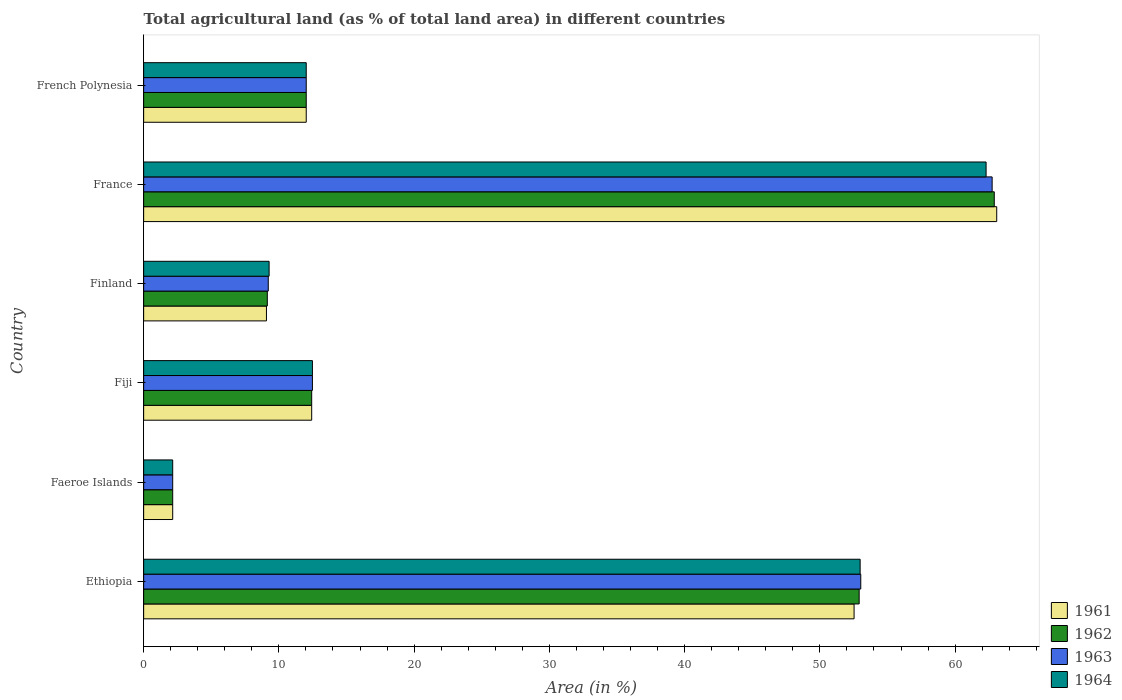How many groups of bars are there?
Give a very brief answer. 6. Are the number of bars on each tick of the Y-axis equal?
Your answer should be very brief. Yes. How many bars are there on the 6th tick from the top?
Keep it short and to the point. 4. What is the label of the 1st group of bars from the top?
Provide a succinct answer. French Polynesia. What is the percentage of agricultural land in 1961 in Finland?
Make the answer very short. 9.08. Across all countries, what is the maximum percentage of agricultural land in 1964?
Your answer should be very brief. 62.29. Across all countries, what is the minimum percentage of agricultural land in 1962?
Provide a succinct answer. 2.15. In which country was the percentage of agricultural land in 1961 minimum?
Provide a succinct answer. Faeroe Islands. What is the total percentage of agricultural land in 1962 in the graph?
Your answer should be compact. 151.54. What is the difference between the percentage of agricultural land in 1962 in Ethiopia and that in Faeroe Islands?
Your response must be concise. 50.76. What is the difference between the percentage of agricultural land in 1962 in Faeroe Islands and the percentage of agricultural land in 1963 in Ethiopia?
Give a very brief answer. -50.88. What is the average percentage of agricultural land in 1961 per country?
Your response must be concise. 25.21. What is the difference between the percentage of agricultural land in 1964 and percentage of agricultural land in 1961 in Fiji?
Make the answer very short. 0.05. In how many countries, is the percentage of agricultural land in 1961 greater than 18 %?
Keep it short and to the point. 2. What is the ratio of the percentage of agricultural land in 1962 in Faeroe Islands to that in France?
Your answer should be compact. 0.03. Is the percentage of agricultural land in 1963 in Faeroe Islands less than that in France?
Offer a terse response. Yes. Is the difference between the percentage of agricultural land in 1964 in France and French Polynesia greater than the difference between the percentage of agricultural land in 1961 in France and French Polynesia?
Your answer should be compact. No. What is the difference between the highest and the second highest percentage of agricultural land in 1964?
Offer a very short reply. 9.31. What is the difference between the highest and the lowest percentage of agricultural land in 1962?
Offer a terse response. 60.75. Is it the case that in every country, the sum of the percentage of agricultural land in 1964 and percentage of agricultural land in 1963 is greater than the sum of percentage of agricultural land in 1961 and percentage of agricultural land in 1962?
Make the answer very short. No. What does the 3rd bar from the top in Fiji represents?
Make the answer very short. 1962. What does the 1st bar from the bottom in France represents?
Provide a succinct answer. 1961. Is it the case that in every country, the sum of the percentage of agricultural land in 1962 and percentage of agricultural land in 1963 is greater than the percentage of agricultural land in 1961?
Provide a short and direct response. Yes. How many bars are there?
Provide a short and direct response. 24. Are all the bars in the graph horizontal?
Ensure brevity in your answer.  Yes. How many countries are there in the graph?
Provide a short and direct response. 6. Are the values on the major ticks of X-axis written in scientific E-notation?
Give a very brief answer. No. Does the graph contain any zero values?
Give a very brief answer. No. Does the graph contain grids?
Your answer should be compact. No. How are the legend labels stacked?
Offer a very short reply. Vertical. What is the title of the graph?
Your answer should be compact. Total agricultural land (as % of total land area) in different countries. What is the label or title of the X-axis?
Your answer should be very brief. Area (in %). What is the label or title of the Y-axis?
Offer a terse response. Country. What is the Area (in %) in 1961 in Ethiopia?
Make the answer very short. 52.53. What is the Area (in %) of 1962 in Ethiopia?
Provide a succinct answer. 52.91. What is the Area (in %) of 1963 in Ethiopia?
Keep it short and to the point. 53.02. What is the Area (in %) in 1964 in Ethiopia?
Ensure brevity in your answer.  52.98. What is the Area (in %) of 1961 in Faeroe Islands?
Give a very brief answer. 2.15. What is the Area (in %) of 1962 in Faeroe Islands?
Your response must be concise. 2.15. What is the Area (in %) of 1963 in Faeroe Islands?
Give a very brief answer. 2.15. What is the Area (in %) in 1964 in Faeroe Islands?
Provide a short and direct response. 2.15. What is the Area (in %) in 1961 in Fiji?
Make the answer very short. 12.42. What is the Area (in %) of 1962 in Fiji?
Provide a short and direct response. 12.42. What is the Area (in %) of 1963 in Fiji?
Offer a terse response. 12.48. What is the Area (in %) of 1964 in Fiji?
Your response must be concise. 12.48. What is the Area (in %) of 1961 in Finland?
Your answer should be compact. 9.08. What is the Area (in %) of 1962 in Finland?
Give a very brief answer. 9.14. What is the Area (in %) in 1963 in Finland?
Ensure brevity in your answer.  9.21. What is the Area (in %) in 1964 in Finland?
Ensure brevity in your answer.  9.28. What is the Area (in %) in 1961 in France?
Your response must be concise. 63.08. What is the Area (in %) in 1962 in France?
Your answer should be very brief. 62.9. What is the Area (in %) of 1963 in France?
Offer a terse response. 62.74. What is the Area (in %) in 1964 in France?
Give a very brief answer. 62.29. What is the Area (in %) in 1961 in French Polynesia?
Keep it short and to the point. 12.02. What is the Area (in %) of 1962 in French Polynesia?
Your answer should be compact. 12.02. What is the Area (in %) in 1963 in French Polynesia?
Give a very brief answer. 12.02. What is the Area (in %) of 1964 in French Polynesia?
Keep it short and to the point. 12.02. Across all countries, what is the maximum Area (in %) in 1961?
Offer a terse response. 63.08. Across all countries, what is the maximum Area (in %) of 1962?
Provide a succinct answer. 62.9. Across all countries, what is the maximum Area (in %) in 1963?
Offer a terse response. 62.74. Across all countries, what is the maximum Area (in %) in 1964?
Make the answer very short. 62.29. Across all countries, what is the minimum Area (in %) in 1961?
Keep it short and to the point. 2.15. Across all countries, what is the minimum Area (in %) in 1962?
Your answer should be compact. 2.15. Across all countries, what is the minimum Area (in %) of 1963?
Ensure brevity in your answer.  2.15. Across all countries, what is the minimum Area (in %) in 1964?
Keep it short and to the point. 2.15. What is the total Area (in %) in 1961 in the graph?
Offer a terse response. 151.28. What is the total Area (in %) of 1962 in the graph?
Give a very brief answer. 151.54. What is the total Area (in %) of 1963 in the graph?
Provide a short and direct response. 151.63. What is the total Area (in %) of 1964 in the graph?
Your answer should be compact. 151.2. What is the difference between the Area (in %) in 1961 in Ethiopia and that in Faeroe Islands?
Give a very brief answer. 50.38. What is the difference between the Area (in %) in 1962 in Ethiopia and that in Faeroe Islands?
Your response must be concise. 50.76. What is the difference between the Area (in %) of 1963 in Ethiopia and that in Faeroe Islands?
Ensure brevity in your answer.  50.88. What is the difference between the Area (in %) of 1964 in Ethiopia and that in Faeroe Islands?
Provide a short and direct response. 50.83. What is the difference between the Area (in %) of 1961 in Ethiopia and that in Fiji?
Make the answer very short. 40.11. What is the difference between the Area (in %) in 1962 in Ethiopia and that in Fiji?
Offer a terse response. 40.48. What is the difference between the Area (in %) in 1963 in Ethiopia and that in Fiji?
Offer a terse response. 40.55. What is the difference between the Area (in %) in 1964 in Ethiopia and that in Fiji?
Your answer should be very brief. 40.5. What is the difference between the Area (in %) in 1961 in Ethiopia and that in Finland?
Offer a very short reply. 43.45. What is the difference between the Area (in %) of 1962 in Ethiopia and that in Finland?
Make the answer very short. 43.76. What is the difference between the Area (in %) in 1963 in Ethiopia and that in Finland?
Make the answer very short. 43.81. What is the difference between the Area (in %) of 1964 in Ethiopia and that in Finland?
Offer a very short reply. 43.7. What is the difference between the Area (in %) in 1961 in Ethiopia and that in France?
Make the answer very short. -10.55. What is the difference between the Area (in %) in 1962 in Ethiopia and that in France?
Keep it short and to the point. -9.99. What is the difference between the Area (in %) of 1963 in Ethiopia and that in France?
Your answer should be compact. -9.71. What is the difference between the Area (in %) in 1964 in Ethiopia and that in France?
Provide a short and direct response. -9.31. What is the difference between the Area (in %) of 1961 in Ethiopia and that in French Polynesia?
Keep it short and to the point. 40.51. What is the difference between the Area (in %) in 1962 in Ethiopia and that in French Polynesia?
Your response must be concise. 40.88. What is the difference between the Area (in %) of 1963 in Ethiopia and that in French Polynesia?
Your answer should be very brief. 41. What is the difference between the Area (in %) of 1964 in Ethiopia and that in French Polynesia?
Offer a very short reply. 40.96. What is the difference between the Area (in %) in 1961 in Faeroe Islands and that in Fiji?
Offer a very short reply. -10.28. What is the difference between the Area (in %) of 1962 in Faeroe Islands and that in Fiji?
Keep it short and to the point. -10.28. What is the difference between the Area (in %) in 1963 in Faeroe Islands and that in Fiji?
Provide a succinct answer. -10.33. What is the difference between the Area (in %) of 1964 in Faeroe Islands and that in Fiji?
Offer a very short reply. -10.33. What is the difference between the Area (in %) in 1961 in Faeroe Islands and that in Finland?
Ensure brevity in your answer.  -6.93. What is the difference between the Area (in %) of 1962 in Faeroe Islands and that in Finland?
Give a very brief answer. -6.99. What is the difference between the Area (in %) in 1963 in Faeroe Islands and that in Finland?
Offer a very short reply. -7.07. What is the difference between the Area (in %) in 1964 in Faeroe Islands and that in Finland?
Your response must be concise. -7.13. What is the difference between the Area (in %) of 1961 in Faeroe Islands and that in France?
Give a very brief answer. -60.93. What is the difference between the Area (in %) in 1962 in Faeroe Islands and that in France?
Provide a short and direct response. -60.75. What is the difference between the Area (in %) in 1963 in Faeroe Islands and that in France?
Make the answer very short. -60.59. What is the difference between the Area (in %) in 1964 in Faeroe Islands and that in France?
Offer a very short reply. -60.14. What is the difference between the Area (in %) in 1961 in Faeroe Islands and that in French Polynesia?
Offer a very short reply. -9.87. What is the difference between the Area (in %) in 1962 in Faeroe Islands and that in French Polynesia?
Offer a very short reply. -9.87. What is the difference between the Area (in %) in 1963 in Faeroe Islands and that in French Polynesia?
Your answer should be very brief. -9.87. What is the difference between the Area (in %) of 1964 in Faeroe Islands and that in French Polynesia?
Keep it short and to the point. -9.87. What is the difference between the Area (in %) in 1961 in Fiji and that in Finland?
Keep it short and to the point. 3.34. What is the difference between the Area (in %) of 1962 in Fiji and that in Finland?
Offer a terse response. 3.28. What is the difference between the Area (in %) in 1963 in Fiji and that in Finland?
Your answer should be compact. 3.27. What is the difference between the Area (in %) of 1964 in Fiji and that in Finland?
Offer a very short reply. 3.2. What is the difference between the Area (in %) of 1961 in Fiji and that in France?
Ensure brevity in your answer.  -50.65. What is the difference between the Area (in %) in 1962 in Fiji and that in France?
Keep it short and to the point. -50.47. What is the difference between the Area (in %) in 1963 in Fiji and that in France?
Your response must be concise. -50.26. What is the difference between the Area (in %) in 1964 in Fiji and that in France?
Give a very brief answer. -49.81. What is the difference between the Area (in %) of 1961 in Fiji and that in French Polynesia?
Offer a terse response. 0.4. What is the difference between the Area (in %) in 1962 in Fiji and that in French Polynesia?
Your answer should be compact. 0.4. What is the difference between the Area (in %) of 1963 in Fiji and that in French Polynesia?
Your answer should be compact. 0.46. What is the difference between the Area (in %) in 1964 in Fiji and that in French Polynesia?
Offer a terse response. 0.46. What is the difference between the Area (in %) of 1961 in Finland and that in France?
Your answer should be very brief. -54. What is the difference between the Area (in %) in 1962 in Finland and that in France?
Give a very brief answer. -53.75. What is the difference between the Area (in %) in 1963 in Finland and that in France?
Offer a terse response. -53.53. What is the difference between the Area (in %) in 1964 in Finland and that in France?
Give a very brief answer. -53.02. What is the difference between the Area (in %) in 1961 in Finland and that in French Polynesia?
Provide a succinct answer. -2.94. What is the difference between the Area (in %) in 1962 in Finland and that in French Polynesia?
Give a very brief answer. -2.88. What is the difference between the Area (in %) in 1963 in Finland and that in French Polynesia?
Ensure brevity in your answer.  -2.81. What is the difference between the Area (in %) of 1964 in Finland and that in French Polynesia?
Your answer should be very brief. -2.75. What is the difference between the Area (in %) of 1961 in France and that in French Polynesia?
Provide a succinct answer. 51.06. What is the difference between the Area (in %) in 1962 in France and that in French Polynesia?
Ensure brevity in your answer.  50.87. What is the difference between the Area (in %) of 1963 in France and that in French Polynesia?
Provide a short and direct response. 50.72. What is the difference between the Area (in %) in 1964 in France and that in French Polynesia?
Ensure brevity in your answer.  50.27. What is the difference between the Area (in %) in 1961 in Ethiopia and the Area (in %) in 1962 in Faeroe Islands?
Your response must be concise. 50.38. What is the difference between the Area (in %) in 1961 in Ethiopia and the Area (in %) in 1963 in Faeroe Islands?
Give a very brief answer. 50.38. What is the difference between the Area (in %) in 1961 in Ethiopia and the Area (in %) in 1964 in Faeroe Islands?
Keep it short and to the point. 50.38. What is the difference between the Area (in %) in 1962 in Ethiopia and the Area (in %) in 1963 in Faeroe Islands?
Your answer should be very brief. 50.76. What is the difference between the Area (in %) of 1962 in Ethiopia and the Area (in %) of 1964 in Faeroe Islands?
Offer a terse response. 50.76. What is the difference between the Area (in %) of 1963 in Ethiopia and the Area (in %) of 1964 in Faeroe Islands?
Offer a very short reply. 50.88. What is the difference between the Area (in %) in 1961 in Ethiopia and the Area (in %) in 1962 in Fiji?
Keep it short and to the point. 40.11. What is the difference between the Area (in %) of 1961 in Ethiopia and the Area (in %) of 1963 in Fiji?
Your answer should be very brief. 40.05. What is the difference between the Area (in %) of 1961 in Ethiopia and the Area (in %) of 1964 in Fiji?
Keep it short and to the point. 40.05. What is the difference between the Area (in %) in 1962 in Ethiopia and the Area (in %) in 1963 in Fiji?
Provide a succinct answer. 40.43. What is the difference between the Area (in %) in 1962 in Ethiopia and the Area (in %) in 1964 in Fiji?
Offer a terse response. 40.43. What is the difference between the Area (in %) in 1963 in Ethiopia and the Area (in %) in 1964 in Fiji?
Your answer should be very brief. 40.55. What is the difference between the Area (in %) in 1961 in Ethiopia and the Area (in %) in 1962 in Finland?
Offer a very short reply. 43.39. What is the difference between the Area (in %) in 1961 in Ethiopia and the Area (in %) in 1963 in Finland?
Give a very brief answer. 43.32. What is the difference between the Area (in %) in 1961 in Ethiopia and the Area (in %) in 1964 in Finland?
Make the answer very short. 43.25. What is the difference between the Area (in %) of 1962 in Ethiopia and the Area (in %) of 1963 in Finland?
Provide a short and direct response. 43.69. What is the difference between the Area (in %) in 1962 in Ethiopia and the Area (in %) in 1964 in Finland?
Provide a succinct answer. 43.63. What is the difference between the Area (in %) in 1963 in Ethiopia and the Area (in %) in 1964 in Finland?
Offer a very short reply. 43.75. What is the difference between the Area (in %) in 1961 in Ethiopia and the Area (in %) in 1962 in France?
Provide a short and direct response. -10.37. What is the difference between the Area (in %) of 1961 in Ethiopia and the Area (in %) of 1963 in France?
Your answer should be very brief. -10.21. What is the difference between the Area (in %) of 1961 in Ethiopia and the Area (in %) of 1964 in France?
Provide a short and direct response. -9.76. What is the difference between the Area (in %) in 1962 in Ethiopia and the Area (in %) in 1963 in France?
Ensure brevity in your answer.  -9.83. What is the difference between the Area (in %) of 1962 in Ethiopia and the Area (in %) of 1964 in France?
Provide a succinct answer. -9.39. What is the difference between the Area (in %) of 1963 in Ethiopia and the Area (in %) of 1964 in France?
Give a very brief answer. -9.27. What is the difference between the Area (in %) of 1961 in Ethiopia and the Area (in %) of 1962 in French Polynesia?
Your answer should be compact. 40.51. What is the difference between the Area (in %) of 1961 in Ethiopia and the Area (in %) of 1963 in French Polynesia?
Your answer should be compact. 40.51. What is the difference between the Area (in %) of 1961 in Ethiopia and the Area (in %) of 1964 in French Polynesia?
Ensure brevity in your answer.  40.51. What is the difference between the Area (in %) in 1962 in Ethiopia and the Area (in %) in 1963 in French Polynesia?
Ensure brevity in your answer.  40.88. What is the difference between the Area (in %) in 1962 in Ethiopia and the Area (in %) in 1964 in French Polynesia?
Ensure brevity in your answer.  40.88. What is the difference between the Area (in %) of 1963 in Ethiopia and the Area (in %) of 1964 in French Polynesia?
Your response must be concise. 41. What is the difference between the Area (in %) of 1961 in Faeroe Islands and the Area (in %) of 1962 in Fiji?
Your response must be concise. -10.28. What is the difference between the Area (in %) of 1961 in Faeroe Islands and the Area (in %) of 1963 in Fiji?
Give a very brief answer. -10.33. What is the difference between the Area (in %) in 1961 in Faeroe Islands and the Area (in %) in 1964 in Fiji?
Keep it short and to the point. -10.33. What is the difference between the Area (in %) of 1962 in Faeroe Islands and the Area (in %) of 1963 in Fiji?
Your answer should be compact. -10.33. What is the difference between the Area (in %) in 1962 in Faeroe Islands and the Area (in %) in 1964 in Fiji?
Your response must be concise. -10.33. What is the difference between the Area (in %) of 1963 in Faeroe Islands and the Area (in %) of 1964 in Fiji?
Make the answer very short. -10.33. What is the difference between the Area (in %) of 1961 in Faeroe Islands and the Area (in %) of 1962 in Finland?
Offer a very short reply. -6.99. What is the difference between the Area (in %) in 1961 in Faeroe Islands and the Area (in %) in 1963 in Finland?
Your response must be concise. -7.07. What is the difference between the Area (in %) of 1961 in Faeroe Islands and the Area (in %) of 1964 in Finland?
Make the answer very short. -7.13. What is the difference between the Area (in %) in 1962 in Faeroe Islands and the Area (in %) in 1963 in Finland?
Keep it short and to the point. -7.07. What is the difference between the Area (in %) of 1962 in Faeroe Islands and the Area (in %) of 1964 in Finland?
Give a very brief answer. -7.13. What is the difference between the Area (in %) in 1963 in Faeroe Islands and the Area (in %) in 1964 in Finland?
Give a very brief answer. -7.13. What is the difference between the Area (in %) in 1961 in Faeroe Islands and the Area (in %) in 1962 in France?
Offer a very short reply. -60.75. What is the difference between the Area (in %) in 1961 in Faeroe Islands and the Area (in %) in 1963 in France?
Keep it short and to the point. -60.59. What is the difference between the Area (in %) in 1961 in Faeroe Islands and the Area (in %) in 1964 in France?
Provide a short and direct response. -60.14. What is the difference between the Area (in %) in 1962 in Faeroe Islands and the Area (in %) in 1963 in France?
Your answer should be compact. -60.59. What is the difference between the Area (in %) in 1962 in Faeroe Islands and the Area (in %) in 1964 in France?
Make the answer very short. -60.14. What is the difference between the Area (in %) of 1963 in Faeroe Islands and the Area (in %) of 1964 in France?
Provide a succinct answer. -60.14. What is the difference between the Area (in %) of 1961 in Faeroe Islands and the Area (in %) of 1962 in French Polynesia?
Provide a short and direct response. -9.87. What is the difference between the Area (in %) in 1961 in Faeroe Islands and the Area (in %) in 1963 in French Polynesia?
Make the answer very short. -9.87. What is the difference between the Area (in %) of 1961 in Faeroe Islands and the Area (in %) of 1964 in French Polynesia?
Ensure brevity in your answer.  -9.87. What is the difference between the Area (in %) in 1962 in Faeroe Islands and the Area (in %) in 1963 in French Polynesia?
Your response must be concise. -9.87. What is the difference between the Area (in %) of 1962 in Faeroe Islands and the Area (in %) of 1964 in French Polynesia?
Your answer should be very brief. -9.87. What is the difference between the Area (in %) in 1963 in Faeroe Islands and the Area (in %) in 1964 in French Polynesia?
Offer a terse response. -9.87. What is the difference between the Area (in %) in 1961 in Fiji and the Area (in %) in 1962 in Finland?
Make the answer very short. 3.28. What is the difference between the Area (in %) in 1961 in Fiji and the Area (in %) in 1963 in Finland?
Keep it short and to the point. 3.21. What is the difference between the Area (in %) of 1961 in Fiji and the Area (in %) of 1964 in Finland?
Offer a terse response. 3.15. What is the difference between the Area (in %) in 1962 in Fiji and the Area (in %) in 1963 in Finland?
Provide a succinct answer. 3.21. What is the difference between the Area (in %) of 1962 in Fiji and the Area (in %) of 1964 in Finland?
Give a very brief answer. 3.15. What is the difference between the Area (in %) in 1963 in Fiji and the Area (in %) in 1964 in Finland?
Your answer should be very brief. 3.2. What is the difference between the Area (in %) in 1961 in Fiji and the Area (in %) in 1962 in France?
Offer a terse response. -50.47. What is the difference between the Area (in %) in 1961 in Fiji and the Area (in %) in 1963 in France?
Ensure brevity in your answer.  -50.31. What is the difference between the Area (in %) in 1961 in Fiji and the Area (in %) in 1964 in France?
Make the answer very short. -49.87. What is the difference between the Area (in %) of 1962 in Fiji and the Area (in %) of 1963 in France?
Provide a succinct answer. -50.31. What is the difference between the Area (in %) in 1962 in Fiji and the Area (in %) in 1964 in France?
Make the answer very short. -49.87. What is the difference between the Area (in %) in 1963 in Fiji and the Area (in %) in 1964 in France?
Ensure brevity in your answer.  -49.81. What is the difference between the Area (in %) in 1961 in Fiji and the Area (in %) in 1962 in French Polynesia?
Make the answer very short. 0.4. What is the difference between the Area (in %) of 1961 in Fiji and the Area (in %) of 1963 in French Polynesia?
Ensure brevity in your answer.  0.4. What is the difference between the Area (in %) of 1961 in Fiji and the Area (in %) of 1964 in French Polynesia?
Your response must be concise. 0.4. What is the difference between the Area (in %) of 1962 in Fiji and the Area (in %) of 1963 in French Polynesia?
Your answer should be compact. 0.4. What is the difference between the Area (in %) of 1962 in Fiji and the Area (in %) of 1964 in French Polynesia?
Provide a succinct answer. 0.4. What is the difference between the Area (in %) in 1963 in Fiji and the Area (in %) in 1964 in French Polynesia?
Ensure brevity in your answer.  0.46. What is the difference between the Area (in %) in 1961 in Finland and the Area (in %) in 1962 in France?
Your answer should be compact. -53.82. What is the difference between the Area (in %) in 1961 in Finland and the Area (in %) in 1963 in France?
Provide a succinct answer. -53.66. What is the difference between the Area (in %) of 1961 in Finland and the Area (in %) of 1964 in France?
Your response must be concise. -53.21. What is the difference between the Area (in %) of 1962 in Finland and the Area (in %) of 1963 in France?
Make the answer very short. -53.6. What is the difference between the Area (in %) of 1962 in Finland and the Area (in %) of 1964 in France?
Your response must be concise. -53.15. What is the difference between the Area (in %) of 1963 in Finland and the Area (in %) of 1964 in France?
Give a very brief answer. -53.08. What is the difference between the Area (in %) in 1961 in Finland and the Area (in %) in 1962 in French Polynesia?
Offer a very short reply. -2.94. What is the difference between the Area (in %) of 1961 in Finland and the Area (in %) of 1963 in French Polynesia?
Make the answer very short. -2.94. What is the difference between the Area (in %) in 1961 in Finland and the Area (in %) in 1964 in French Polynesia?
Your answer should be very brief. -2.94. What is the difference between the Area (in %) of 1962 in Finland and the Area (in %) of 1963 in French Polynesia?
Give a very brief answer. -2.88. What is the difference between the Area (in %) of 1962 in Finland and the Area (in %) of 1964 in French Polynesia?
Ensure brevity in your answer.  -2.88. What is the difference between the Area (in %) in 1963 in Finland and the Area (in %) in 1964 in French Polynesia?
Ensure brevity in your answer.  -2.81. What is the difference between the Area (in %) in 1961 in France and the Area (in %) in 1962 in French Polynesia?
Make the answer very short. 51.06. What is the difference between the Area (in %) in 1961 in France and the Area (in %) in 1963 in French Polynesia?
Give a very brief answer. 51.06. What is the difference between the Area (in %) in 1961 in France and the Area (in %) in 1964 in French Polynesia?
Your response must be concise. 51.06. What is the difference between the Area (in %) of 1962 in France and the Area (in %) of 1963 in French Polynesia?
Ensure brevity in your answer.  50.87. What is the difference between the Area (in %) in 1962 in France and the Area (in %) in 1964 in French Polynesia?
Provide a short and direct response. 50.87. What is the difference between the Area (in %) of 1963 in France and the Area (in %) of 1964 in French Polynesia?
Make the answer very short. 50.72. What is the average Area (in %) of 1961 per country?
Make the answer very short. 25.21. What is the average Area (in %) of 1962 per country?
Keep it short and to the point. 25.26. What is the average Area (in %) of 1963 per country?
Provide a short and direct response. 25.27. What is the average Area (in %) of 1964 per country?
Provide a succinct answer. 25.2. What is the difference between the Area (in %) in 1961 and Area (in %) in 1962 in Ethiopia?
Give a very brief answer. -0.38. What is the difference between the Area (in %) of 1961 and Area (in %) of 1963 in Ethiopia?
Make the answer very short. -0.49. What is the difference between the Area (in %) in 1961 and Area (in %) in 1964 in Ethiopia?
Provide a short and direct response. -0.45. What is the difference between the Area (in %) of 1962 and Area (in %) of 1963 in Ethiopia?
Offer a terse response. -0.12. What is the difference between the Area (in %) in 1962 and Area (in %) in 1964 in Ethiopia?
Provide a succinct answer. -0.07. What is the difference between the Area (in %) in 1963 and Area (in %) in 1964 in Ethiopia?
Your answer should be compact. 0.05. What is the difference between the Area (in %) of 1961 and Area (in %) of 1962 in Faeroe Islands?
Keep it short and to the point. 0. What is the difference between the Area (in %) in 1961 and Area (in %) in 1964 in Faeroe Islands?
Your response must be concise. 0. What is the difference between the Area (in %) in 1962 and Area (in %) in 1963 in Faeroe Islands?
Your answer should be compact. 0. What is the difference between the Area (in %) in 1962 and Area (in %) in 1964 in Faeroe Islands?
Your response must be concise. 0. What is the difference between the Area (in %) of 1961 and Area (in %) of 1963 in Fiji?
Your response must be concise. -0.05. What is the difference between the Area (in %) of 1961 and Area (in %) of 1964 in Fiji?
Your response must be concise. -0.05. What is the difference between the Area (in %) of 1962 and Area (in %) of 1963 in Fiji?
Your answer should be compact. -0.05. What is the difference between the Area (in %) of 1962 and Area (in %) of 1964 in Fiji?
Provide a short and direct response. -0.05. What is the difference between the Area (in %) of 1963 and Area (in %) of 1964 in Fiji?
Make the answer very short. 0. What is the difference between the Area (in %) in 1961 and Area (in %) in 1962 in Finland?
Offer a terse response. -0.06. What is the difference between the Area (in %) in 1961 and Area (in %) in 1963 in Finland?
Provide a short and direct response. -0.13. What is the difference between the Area (in %) of 1961 and Area (in %) of 1964 in Finland?
Provide a short and direct response. -0.2. What is the difference between the Area (in %) of 1962 and Area (in %) of 1963 in Finland?
Your answer should be very brief. -0.07. What is the difference between the Area (in %) in 1962 and Area (in %) in 1964 in Finland?
Your answer should be very brief. -0.13. What is the difference between the Area (in %) of 1963 and Area (in %) of 1964 in Finland?
Make the answer very short. -0.06. What is the difference between the Area (in %) in 1961 and Area (in %) in 1962 in France?
Your answer should be compact. 0.18. What is the difference between the Area (in %) of 1961 and Area (in %) of 1963 in France?
Your answer should be compact. 0.34. What is the difference between the Area (in %) in 1961 and Area (in %) in 1964 in France?
Give a very brief answer. 0.79. What is the difference between the Area (in %) of 1962 and Area (in %) of 1963 in France?
Offer a terse response. 0.16. What is the difference between the Area (in %) of 1962 and Area (in %) of 1964 in France?
Your response must be concise. 0.6. What is the difference between the Area (in %) of 1963 and Area (in %) of 1964 in France?
Your answer should be compact. 0.45. What is the difference between the Area (in %) in 1961 and Area (in %) in 1962 in French Polynesia?
Make the answer very short. 0. What is the difference between the Area (in %) in 1961 and Area (in %) in 1964 in French Polynesia?
Ensure brevity in your answer.  0. What is the difference between the Area (in %) in 1962 and Area (in %) in 1963 in French Polynesia?
Your answer should be compact. 0. What is the difference between the Area (in %) in 1962 and Area (in %) in 1964 in French Polynesia?
Offer a terse response. 0. What is the ratio of the Area (in %) in 1961 in Ethiopia to that in Faeroe Islands?
Provide a short and direct response. 24.44. What is the ratio of the Area (in %) in 1962 in Ethiopia to that in Faeroe Islands?
Your answer should be very brief. 24.62. What is the ratio of the Area (in %) in 1963 in Ethiopia to that in Faeroe Islands?
Your answer should be compact. 24.67. What is the ratio of the Area (in %) of 1964 in Ethiopia to that in Faeroe Islands?
Provide a short and direct response. 24.65. What is the ratio of the Area (in %) in 1961 in Ethiopia to that in Fiji?
Ensure brevity in your answer.  4.23. What is the ratio of the Area (in %) in 1962 in Ethiopia to that in Fiji?
Your answer should be very brief. 4.26. What is the ratio of the Area (in %) in 1963 in Ethiopia to that in Fiji?
Ensure brevity in your answer.  4.25. What is the ratio of the Area (in %) of 1964 in Ethiopia to that in Fiji?
Make the answer very short. 4.25. What is the ratio of the Area (in %) in 1961 in Ethiopia to that in Finland?
Offer a terse response. 5.79. What is the ratio of the Area (in %) of 1962 in Ethiopia to that in Finland?
Your answer should be compact. 5.79. What is the ratio of the Area (in %) in 1963 in Ethiopia to that in Finland?
Give a very brief answer. 5.75. What is the ratio of the Area (in %) of 1964 in Ethiopia to that in Finland?
Give a very brief answer. 5.71. What is the ratio of the Area (in %) of 1961 in Ethiopia to that in France?
Your answer should be very brief. 0.83. What is the ratio of the Area (in %) in 1962 in Ethiopia to that in France?
Your answer should be very brief. 0.84. What is the ratio of the Area (in %) in 1963 in Ethiopia to that in France?
Ensure brevity in your answer.  0.85. What is the ratio of the Area (in %) of 1964 in Ethiopia to that in France?
Make the answer very short. 0.85. What is the ratio of the Area (in %) in 1961 in Ethiopia to that in French Polynesia?
Offer a very short reply. 4.37. What is the ratio of the Area (in %) of 1962 in Ethiopia to that in French Polynesia?
Provide a short and direct response. 4.4. What is the ratio of the Area (in %) of 1963 in Ethiopia to that in French Polynesia?
Ensure brevity in your answer.  4.41. What is the ratio of the Area (in %) in 1964 in Ethiopia to that in French Polynesia?
Give a very brief answer. 4.41. What is the ratio of the Area (in %) in 1961 in Faeroe Islands to that in Fiji?
Provide a succinct answer. 0.17. What is the ratio of the Area (in %) in 1962 in Faeroe Islands to that in Fiji?
Your answer should be compact. 0.17. What is the ratio of the Area (in %) in 1963 in Faeroe Islands to that in Fiji?
Keep it short and to the point. 0.17. What is the ratio of the Area (in %) in 1964 in Faeroe Islands to that in Fiji?
Provide a short and direct response. 0.17. What is the ratio of the Area (in %) in 1961 in Faeroe Islands to that in Finland?
Keep it short and to the point. 0.24. What is the ratio of the Area (in %) of 1962 in Faeroe Islands to that in Finland?
Your response must be concise. 0.23. What is the ratio of the Area (in %) of 1963 in Faeroe Islands to that in Finland?
Your response must be concise. 0.23. What is the ratio of the Area (in %) of 1964 in Faeroe Islands to that in Finland?
Ensure brevity in your answer.  0.23. What is the ratio of the Area (in %) in 1961 in Faeroe Islands to that in France?
Provide a succinct answer. 0.03. What is the ratio of the Area (in %) in 1962 in Faeroe Islands to that in France?
Make the answer very short. 0.03. What is the ratio of the Area (in %) in 1963 in Faeroe Islands to that in France?
Offer a very short reply. 0.03. What is the ratio of the Area (in %) in 1964 in Faeroe Islands to that in France?
Provide a short and direct response. 0.03. What is the ratio of the Area (in %) of 1961 in Faeroe Islands to that in French Polynesia?
Your response must be concise. 0.18. What is the ratio of the Area (in %) of 1962 in Faeroe Islands to that in French Polynesia?
Your response must be concise. 0.18. What is the ratio of the Area (in %) of 1963 in Faeroe Islands to that in French Polynesia?
Your answer should be compact. 0.18. What is the ratio of the Area (in %) in 1964 in Faeroe Islands to that in French Polynesia?
Provide a short and direct response. 0.18. What is the ratio of the Area (in %) in 1961 in Fiji to that in Finland?
Give a very brief answer. 1.37. What is the ratio of the Area (in %) of 1962 in Fiji to that in Finland?
Provide a short and direct response. 1.36. What is the ratio of the Area (in %) in 1963 in Fiji to that in Finland?
Give a very brief answer. 1.35. What is the ratio of the Area (in %) of 1964 in Fiji to that in Finland?
Offer a terse response. 1.35. What is the ratio of the Area (in %) in 1961 in Fiji to that in France?
Your answer should be very brief. 0.2. What is the ratio of the Area (in %) in 1962 in Fiji to that in France?
Your response must be concise. 0.2. What is the ratio of the Area (in %) in 1963 in Fiji to that in France?
Your answer should be very brief. 0.2. What is the ratio of the Area (in %) of 1964 in Fiji to that in France?
Ensure brevity in your answer.  0.2. What is the ratio of the Area (in %) in 1961 in Fiji to that in French Polynesia?
Ensure brevity in your answer.  1.03. What is the ratio of the Area (in %) of 1962 in Fiji to that in French Polynesia?
Your response must be concise. 1.03. What is the ratio of the Area (in %) in 1963 in Fiji to that in French Polynesia?
Your answer should be very brief. 1.04. What is the ratio of the Area (in %) in 1964 in Fiji to that in French Polynesia?
Your answer should be compact. 1.04. What is the ratio of the Area (in %) of 1961 in Finland to that in France?
Keep it short and to the point. 0.14. What is the ratio of the Area (in %) of 1962 in Finland to that in France?
Make the answer very short. 0.15. What is the ratio of the Area (in %) of 1963 in Finland to that in France?
Your answer should be very brief. 0.15. What is the ratio of the Area (in %) in 1964 in Finland to that in France?
Your answer should be compact. 0.15. What is the ratio of the Area (in %) in 1961 in Finland to that in French Polynesia?
Provide a succinct answer. 0.76. What is the ratio of the Area (in %) in 1962 in Finland to that in French Polynesia?
Provide a succinct answer. 0.76. What is the ratio of the Area (in %) of 1963 in Finland to that in French Polynesia?
Your response must be concise. 0.77. What is the ratio of the Area (in %) of 1964 in Finland to that in French Polynesia?
Your answer should be very brief. 0.77. What is the ratio of the Area (in %) in 1961 in France to that in French Polynesia?
Give a very brief answer. 5.25. What is the ratio of the Area (in %) in 1962 in France to that in French Polynesia?
Offer a very short reply. 5.23. What is the ratio of the Area (in %) of 1963 in France to that in French Polynesia?
Make the answer very short. 5.22. What is the ratio of the Area (in %) of 1964 in France to that in French Polynesia?
Keep it short and to the point. 5.18. What is the difference between the highest and the second highest Area (in %) in 1961?
Offer a terse response. 10.55. What is the difference between the highest and the second highest Area (in %) of 1962?
Give a very brief answer. 9.99. What is the difference between the highest and the second highest Area (in %) of 1963?
Offer a terse response. 9.71. What is the difference between the highest and the second highest Area (in %) in 1964?
Your response must be concise. 9.31. What is the difference between the highest and the lowest Area (in %) in 1961?
Your answer should be compact. 60.93. What is the difference between the highest and the lowest Area (in %) of 1962?
Your answer should be compact. 60.75. What is the difference between the highest and the lowest Area (in %) in 1963?
Keep it short and to the point. 60.59. What is the difference between the highest and the lowest Area (in %) of 1964?
Ensure brevity in your answer.  60.14. 